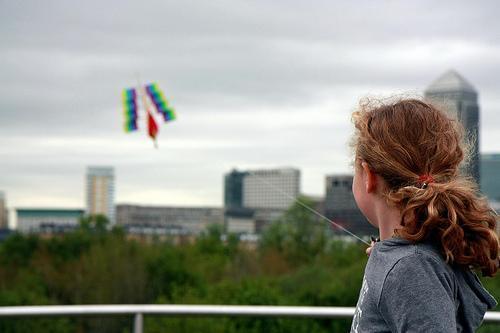How many kites do you see?
Give a very brief answer. 1. 